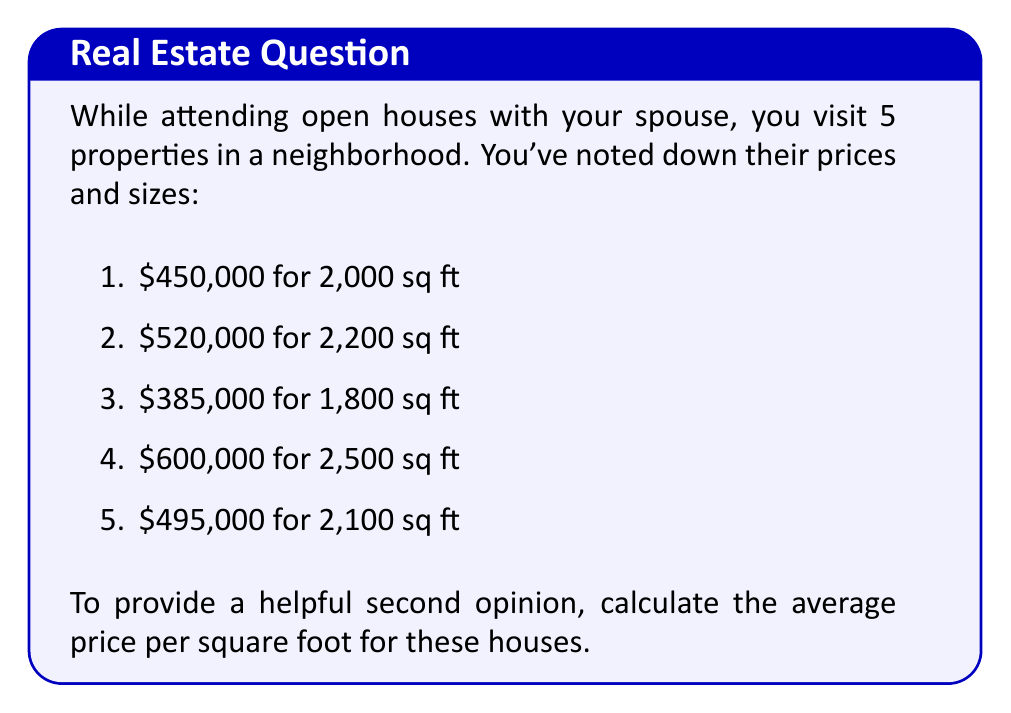Help me with this question. To calculate the average price per square foot, we'll follow these steps:

1. Calculate the price per square foot for each house:
   House 1: $\frac{450,000}{2,000} = 225$ $/sq ft
   House 2: $\frac{520,000}{2,200} = 236.36$ $/sq ft
   House 3: $\frac{385,000}{1,800} = 213.89$ $/sq ft
   House 4: $\frac{600,000}{2,500} = 240$ $/sq ft
   House 5: $\frac{495,000}{2,100} = 235.71$ $/sq ft

2. Sum up all the price per square foot values:
   $225 + 236.36 + 213.89 + 240 + 235.71 = 1150.96$

3. Divide the sum by the number of houses (5) to get the average:
   $\frac{1150.96}{5} = 230.192$

Therefore, the average price per square foot is $230.192 per square foot.
Answer: $230.19 per square foot (rounded to two decimal places) 